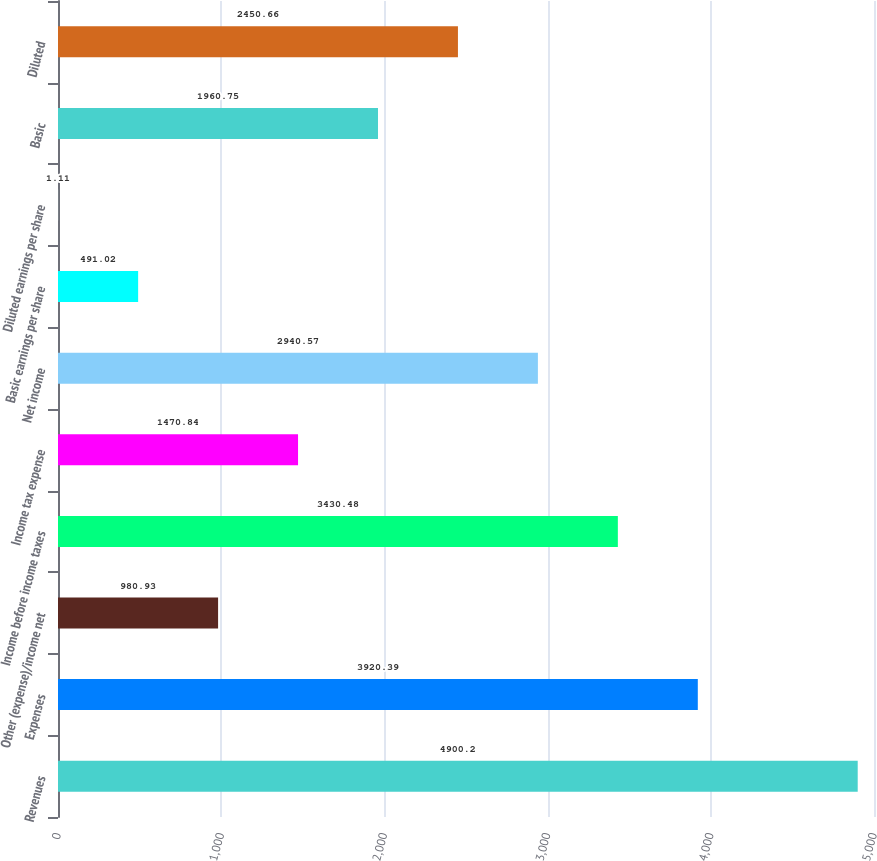Convert chart. <chart><loc_0><loc_0><loc_500><loc_500><bar_chart><fcel>Revenues<fcel>Expenses<fcel>Other (expense)/income net<fcel>Income before income taxes<fcel>Income tax expense<fcel>Net income<fcel>Basic earnings per share<fcel>Diluted earnings per share<fcel>Basic<fcel>Diluted<nl><fcel>4900.2<fcel>3920.39<fcel>980.93<fcel>3430.48<fcel>1470.84<fcel>2940.57<fcel>491.02<fcel>1.11<fcel>1960.75<fcel>2450.66<nl></chart> 